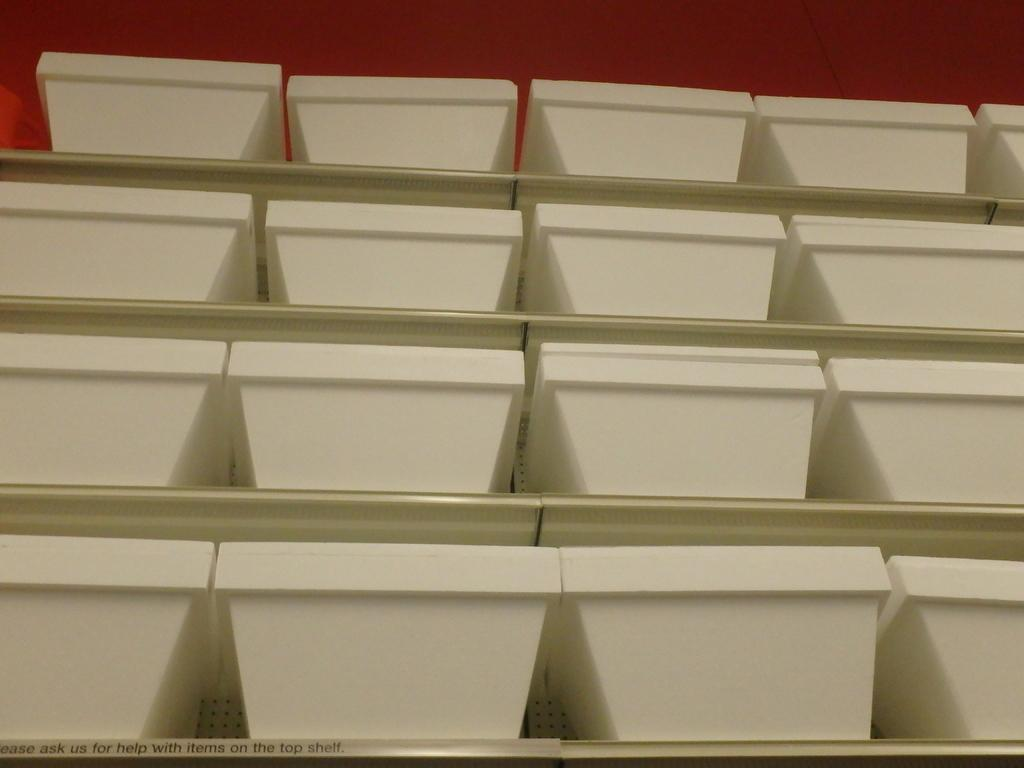What objects are present in the image? There are many bowls in the image. Where are the bowls located? The bowls are kept in shelves. What color are the bowls? The bowls are of white color. How many trains can be seen in the image? There are no trains present in the image; it features many bowls kept in shelves. 